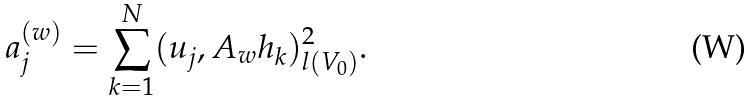<formula> <loc_0><loc_0><loc_500><loc_500>a _ { j } ^ { ( w ) } = \sum _ { k = 1 } ^ { N } ( u _ { j } , A _ { w } h _ { k } ) _ { l ( V _ { 0 } ) } ^ { 2 } .</formula> 